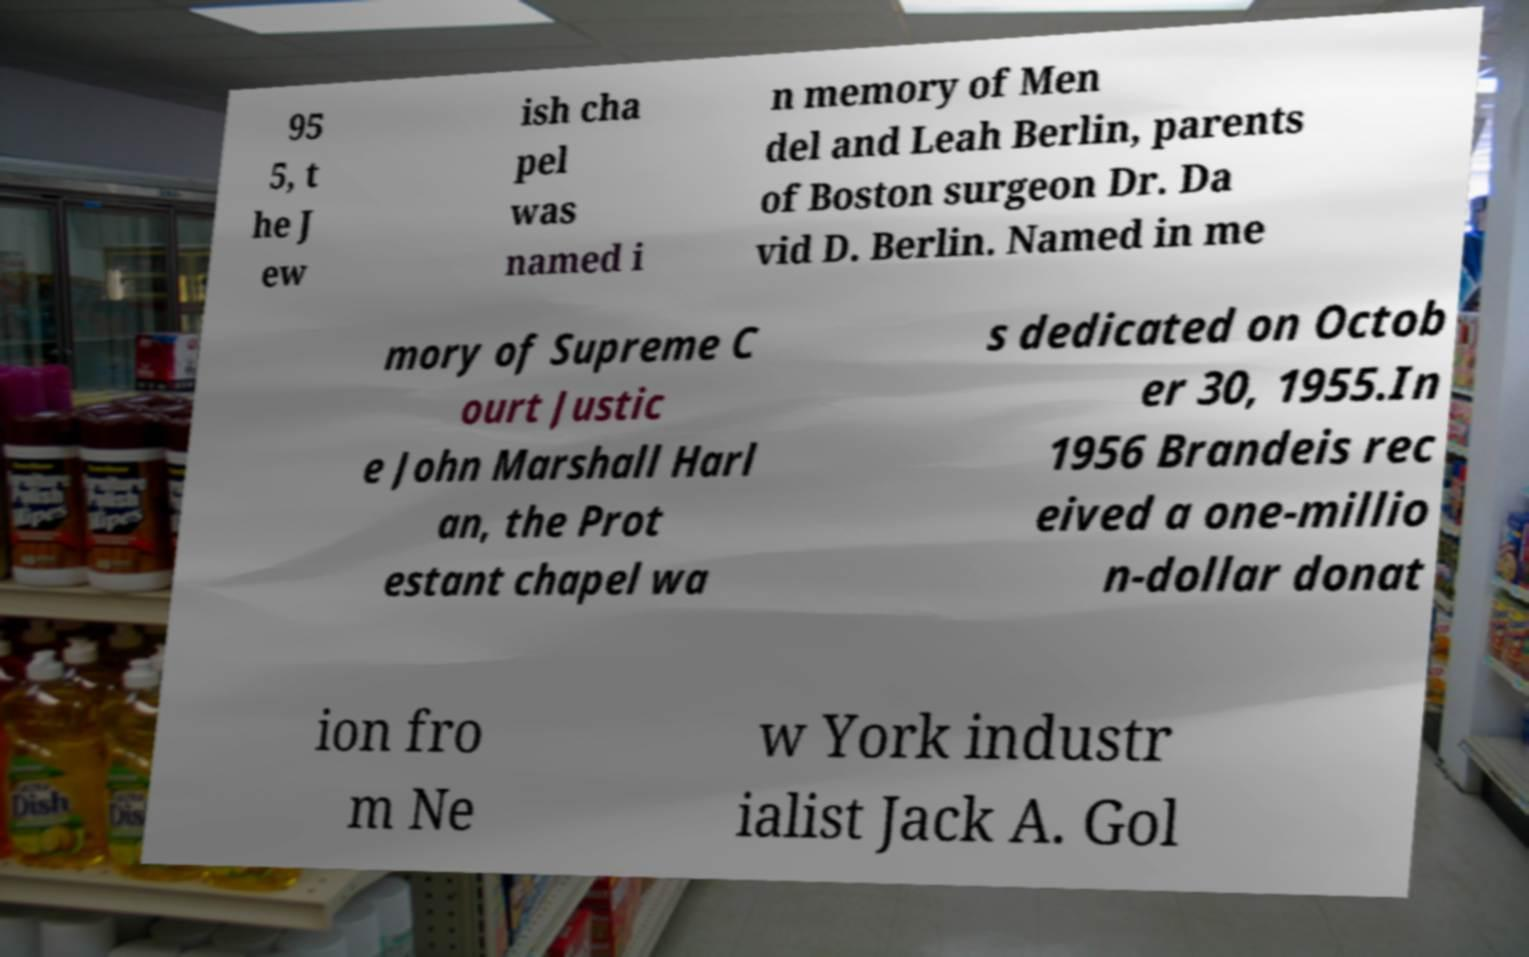For documentation purposes, I need the text within this image transcribed. Could you provide that? 95 5, t he J ew ish cha pel was named i n memory of Men del and Leah Berlin, parents of Boston surgeon Dr. Da vid D. Berlin. Named in me mory of Supreme C ourt Justic e John Marshall Harl an, the Prot estant chapel wa s dedicated on Octob er 30, 1955.In 1956 Brandeis rec eived a one-millio n-dollar donat ion fro m Ne w York industr ialist Jack A. Gol 